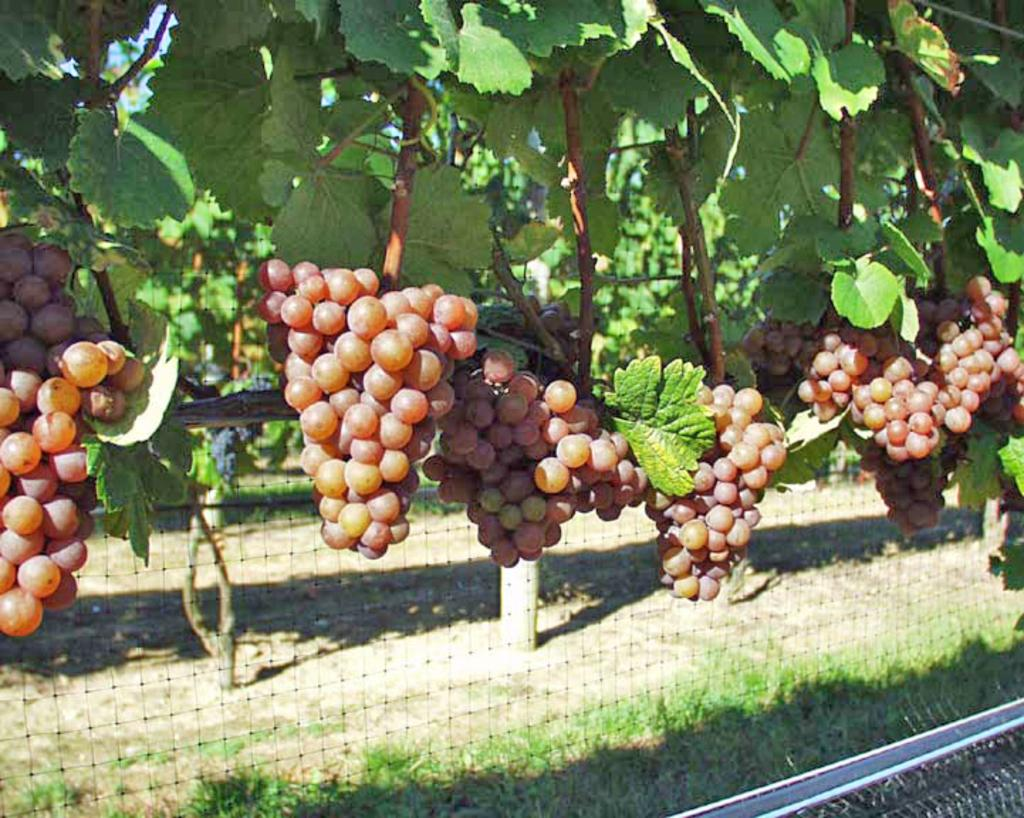What type of fruit can be seen on the tree in the image? There are grapes on a tree in the image. What is present in the background of the image? There is a net and trees in the background of the image. What type of smoke can be seen coming from the grapes in the image? There is no smoke present in the image; it features grapes on a tree and a net in the background. 